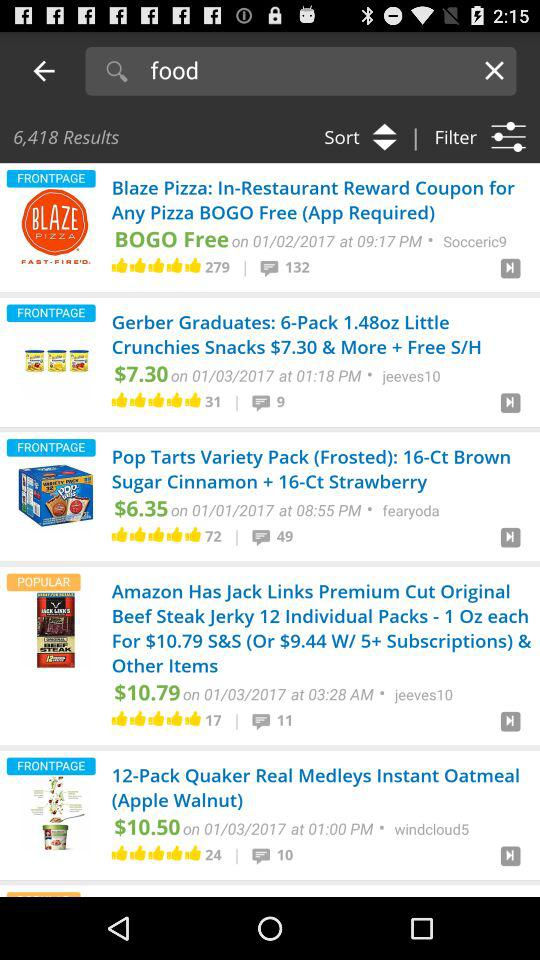How many people have commented for "Pop Tarts Variety Pack"? There are 49 comments. 